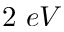Convert formula to latex. <formula><loc_0><loc_0><loc_500><loc_500>2 e V</formula> 